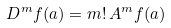<formula> <loc_0><loc_0><loc_500><loc_500>D ^ { m } f ( a ) = m ! \, A ^ { m } f ( a )</formula> 